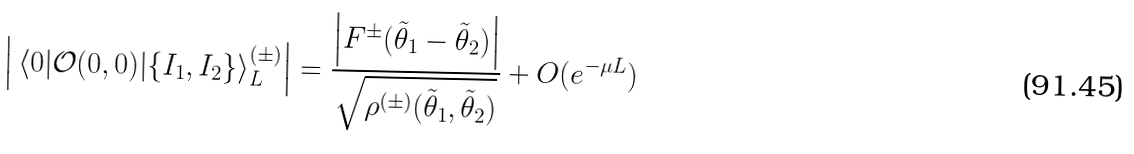<formula> <loc_0><loc_0><loc_500><loc_500>\left | \, \langle 0 | \mathcal { O } ( 0 , 0 ) | \{ I _ { 1 } , I _ { 2 } \} \rangle _ { L } ^ { ( \pm ) } \right | = \frac { \left | F ^ { \pm } ( \tilde { \theta } _ { 1 } - \tilde { \theta } _ { 2 } ) \right | } { \sqrt { \rho ^ { ( \pm ) } ( \tilde { \theta } _ { 1 } , \tilde { \theta } _ { 2 } ) } } + O ( e ^ { - \mu L } )</formula> 